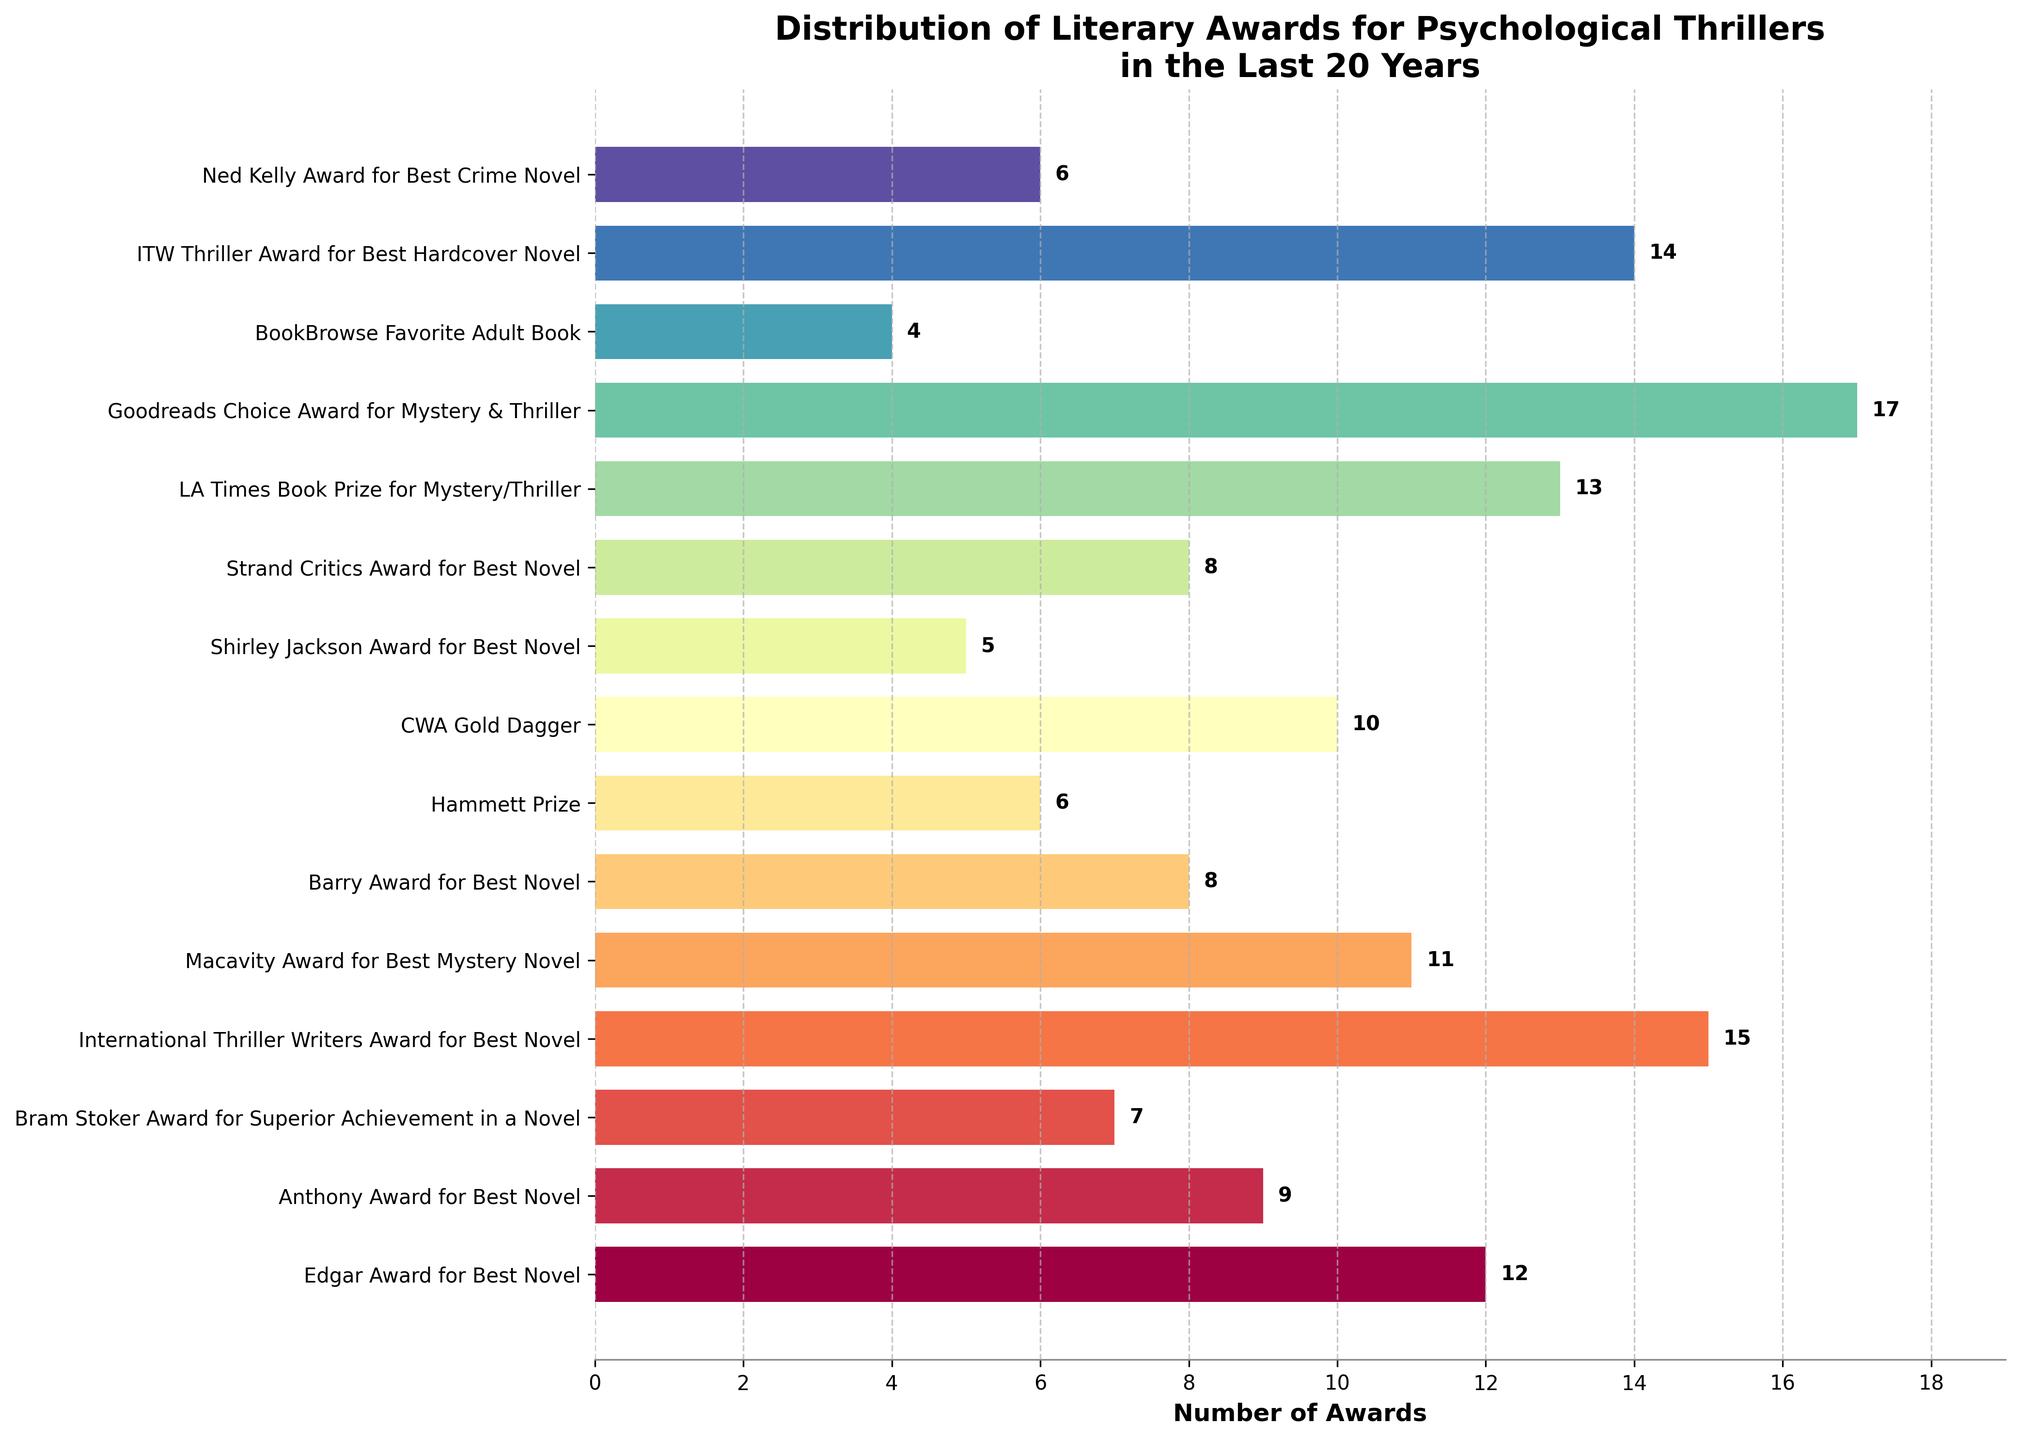What's the most awarded category for psychological thrillers in the last 20 years? To find the most awarded category, look for the bar with the highest value. "Goodreads Choice Award for Mystery & Thriller" has the highest number of awards, 17.
Answer: Goodreads Choice Award for Mystery & Thriller Which award category has more awards: ITW Thriller Award for Best Hardcover Novel or CWA Gold Dagger? Refer to the bars for "ITW Thriller Award for Best Hardcover Novel" and "CWA Gold Dagger". The "ITW Thriller Award for Best Hardcover Novel" has 14 awards, while "CWA Gold Dagger" has 10 awards.
Answer: ITW Thriller Award for Best Hardcover Novel How many awards did the Edgar Award and Macavity Award combined receive? Sum the values for "Edgar Award for Best Novel" (12) and "Macavity Award for Best Mystery Novel" (11). 12 + 11 = 23.
Answer: 23 What’s the difference in the number of awards between Anthony Award for Best Novel and Bram Stoker Award for Superior Achievement in a Novel? Subtract the number of awards for "Bram Stoker Award for Superior Achievement in a Novel" (7) from "Anthony Award for Best Novel" (9). 9 - 7 = 2.
Answer: 2 Which award category has the least number of awards? Identify the bar with the smallest value. "BookBrowse Favorite Adult Book" has the lowest number of awards, 4.
Answer: BookBrowse Favorite Adult Book How many award categories have received 10 or more awards? Count the bars with values of 10 or higher. There are 7 categories: Edgar Award (12), International Thriller Writers Award (15), Macavity Award (11), LA Times Book Prize (13), Goodreads (17), ITW Thriller Award (14), and CWA Gold Dagger (10).
Answer: 7 Which awards have exactly the same number of awards, and how many? Look for categories with bars of equal length. "Barry Award for Best Novel" and "Strand Critics Award for Best Novel" both have 8 awards.
Answer: Barry Award and Strand Critics Award, 8 